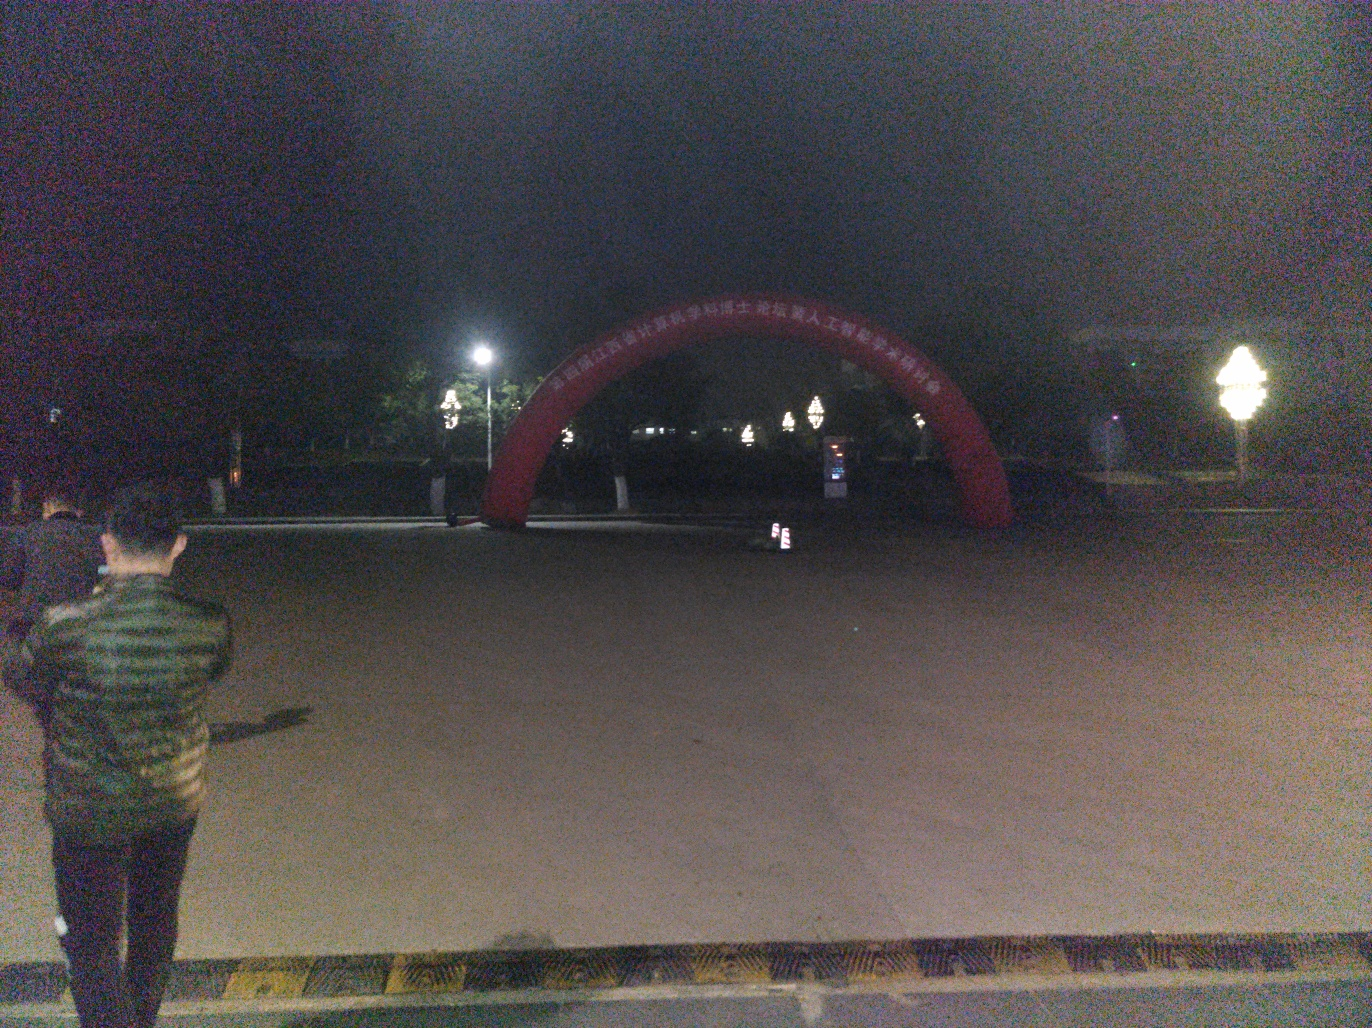Are the light parts properly exposed? The exposure of the light parts in the image seems to be underexposed rather than properly exposed, which is common in low-light conditions. This results in less detail and a darker image overall. Proper exposure would ensure that details are visible in both the light and dark parts of the image. 